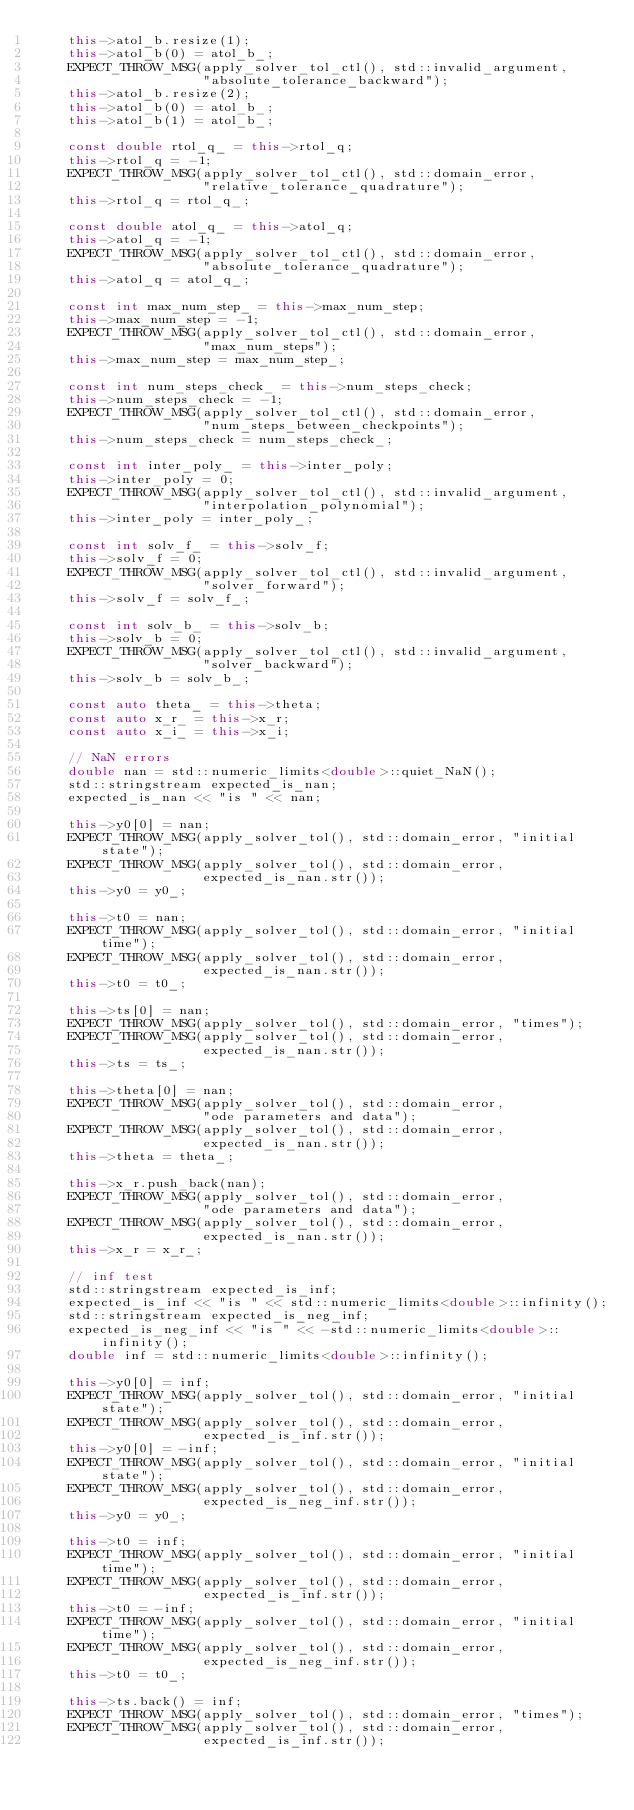Convert code to text. <code><loc_0><loc_0><loc_500><loc_500><_C++_>    this->atol_b.resize(1);
    this->atol_b(0) = atol_b_;
    EXPECT_THROW_MSG(apply_solver_tol_ctl(), std::invalid_argument,
                     "absolute_tolerance_backward");
    this->atol_b.resize(2);
    this->atol_b(0) = atol_b_;
    this->atol_b(1) = atol_b_;

    const double rtol_q_ = this->rtol_q;
    this->rtol_q = -1;
    EXPECT_THROW_MSG(apply_solver_tol_ctl(), std::domain_error,
                     "relative_tolerance_quadrature");
    this->rtol_q = rtol_q_;

    const double atol_q_ = this->atol_q;
    this->atol_q = -1;
    EXPECT_THROW_MSG(apply_solver_tol_ctl(), std::domain_error,
                     "absolute_tolerance_quadrature");
    this->atol_q = atol_q_;

    const int max_num_step_ = this->max_num_step;
    this->max_num_step = -1;
    EXPECT_THROW_MSG(apply_solver_tol_ctl(), std::domain_error,
                     "max_num_steps");
    this->max_num_step = max_num_step_;

    const int num_steps_check_ = this->num_steps_check;
    this->num_steps_check = -1;
    EXPECT_THROW_MSG(apply_solver_tol_ctl(), std::domain_error,
                     "num_steps_between_checkpoints");
    this->num_steps_check = num_steps_check_;

    const int inter_poly_ = this->inter_poly;
    this->inter_poly = 0;
    EXPECT_THROW_MSG(apply_solver_tol_ctl(), std::invalid_argument,
                     "interpolation_polynomial");
    this->inter_poly = inter_poly_;

    const int solv_f_ = this->solv_f;
    this->solv_f = 0;
    EXPECT_THROW_MSG(apply_solver_tol_ctl(), std::invalid_argument,
                     "solver_forward");
    this->solv_f = solv_f_;

    const int solv_b_ = this->solv_b;
    this->solv_b = 0;
    EXPECT_THROW_MSG(apply_solver_tol_ctl(), std::invalid_argument,
                     "solver_backward");
    this->solv_b = solv_b_;

    const auto theta_ = this->theta;
    const auto x_r_ = this->x_r;
    const auto x_i_ = this->x_i;

    // NaN errors
    double nan = std::numeric_limits<double>::quiet_NaN();
    std::stringstream expected_is_nan;
    expected_is_nan << "is " << nan;

    this->y0[0] = nan;
    EXPECT_THROW_MSG(apply_solver_tol(), std::domain_error, "initial state");
    EXPECT_THROW_MSG(apply_solver_tol(), std::domain_error,
                     expected_is_nan.str());
    this->y0 = y0_;

    this->t0 = nan;
    EXPECT_THROW_MSG(apply_solver_tol(), std::domain_error, "initial time");
    EXPECT_THROW_MSG(apply_solver_tol(), std::domain_error,
                     expected_is_nan.str());
    this->t0 = t0_;

    this->ts[0] = nan;
    EXPECT_THROW_MSG(apply_solver_tol(), std::domain_error, "times");
    EXPECT_THROW_MSG(apply_solver_tol(), std::domain_error,
                     expected_is_nan.str());
    this->ts = ts_;

    this->theta[0] = nan;
    EXPECT_THROW_MSG(apply_solver_tol(), std::domain_error,
                     "ode parameters and data");
    EXPECT_THROW_MSG(apply_solver_tol(), std::domain_error,
                     expected_is_nan.str());
    this->theta = theta_;

    this->x_r.push_back(nan);
    EXPECT_THROW_MSG(apply_solver_tol(), std::domain_error,
                     "ode parameters and data");
    EXPECT_THROW_MSG(apply_solver_tol(), std::domain_error,
                     expected_is_nan.str());
    this->x_r = x_r_;

    // inf test
    std::stringstream expected_is_inf;
    expected_is_inf << "is " << std::numeric_limits<double>::infinity();
    std::stringstream expected_is_neg_inf;
    expected_is_neg_inf << "is " << -std::numeric_limits<double>::infinity();
    double inf = std::numeric_limits<double>::infinity();

    this->y0[0] = inf;
    EXPECT_THROW_MSG(apply_solver_tol(), std::domain_error, "initial state");
    EXPECT_THROW_MSG(apply_solver_tol(), std::domain_error,
                     expected_is_inf.str());
    this->y0[0] = -inf;
    EXPECT_THROW_MSG(apply_solver_tol(), std::domain_error, "initial state");
    EXPECT_THROW_MSG(apply_solver_tol(), std::domain_error,
                     expected_is_neg_inf.str());
    this->y0 = y0_;

    this->t0 = inf;
    EXPECT_THROW_MSG(apply_solver_tol(), std::domain_error, "initial time");
    EXPECT_THROW_MSG(apply_solver_tol(), std::domain_error,
                     expected_is_inf.str());
    this->t0 = -inf;
    EXPECT_THROW_MSG(apply_solver_tol(), std::domain_error, "initial time");
    EXPECT_THROW_MSG(apply_solver_tol(), std::domain_error,
                     expected_is_neg_inf.str());
    this->t0 = t0_;

    this->ts.back() = inf;
    EXPECT_THROW_MSG(apply_solver_tol(), std::domain_error, "times");
    EXPECT_THROW_MSG(apply_solver_tol(), std::domain_error,
                     expected_is_inf.str());</code> 